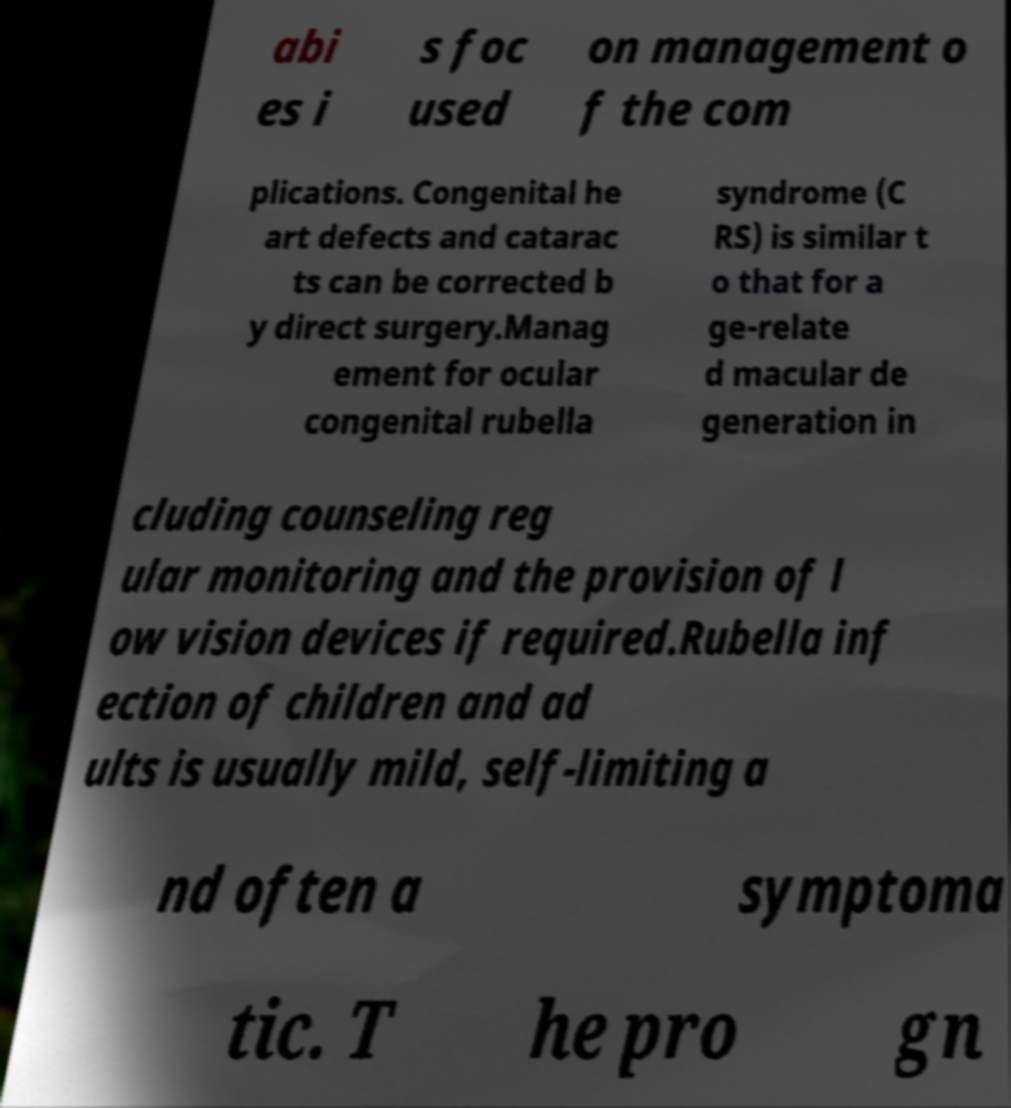Can you read and provide the text displayed in the image?This photo seems to have some interesting text. Can you extract and type it out for me? abi es i s foc used on management o f the com plications. Congenital he art defects and catarac ts can be corrected b y direct surgery.Manag ement for ocular congenital rubella syndrome (C RS) is similar t o that for a ge-relate d macular de generation in cluding counseling reg ular monitoring and the provision of l ow vision devices if required.Rubella inf ection of children and ad ults is usually mild, self-limiting a nd often a symptoma tic. T he pro gn 